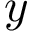Convert formula to latex. <formula><loc_0><loc_0><loc_500><loc_500>y</formula> 